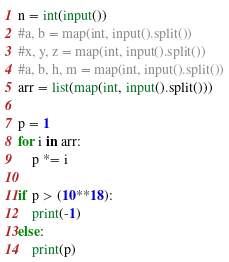Convert code to text. <code><loc_0><loc_0><loc_500><loc_500><_Python_>n = int(input())
#a, b = map(int, input().split())
#x, y, z = map(int, input().split())
#a, b, h, m = map(int, input().split())
arr = list(map(int, input().split()))

p = 1
for i in arr:
	p *= i
		
if p > (10**18):
	print(-1)
else:
	print(p)
</code> 